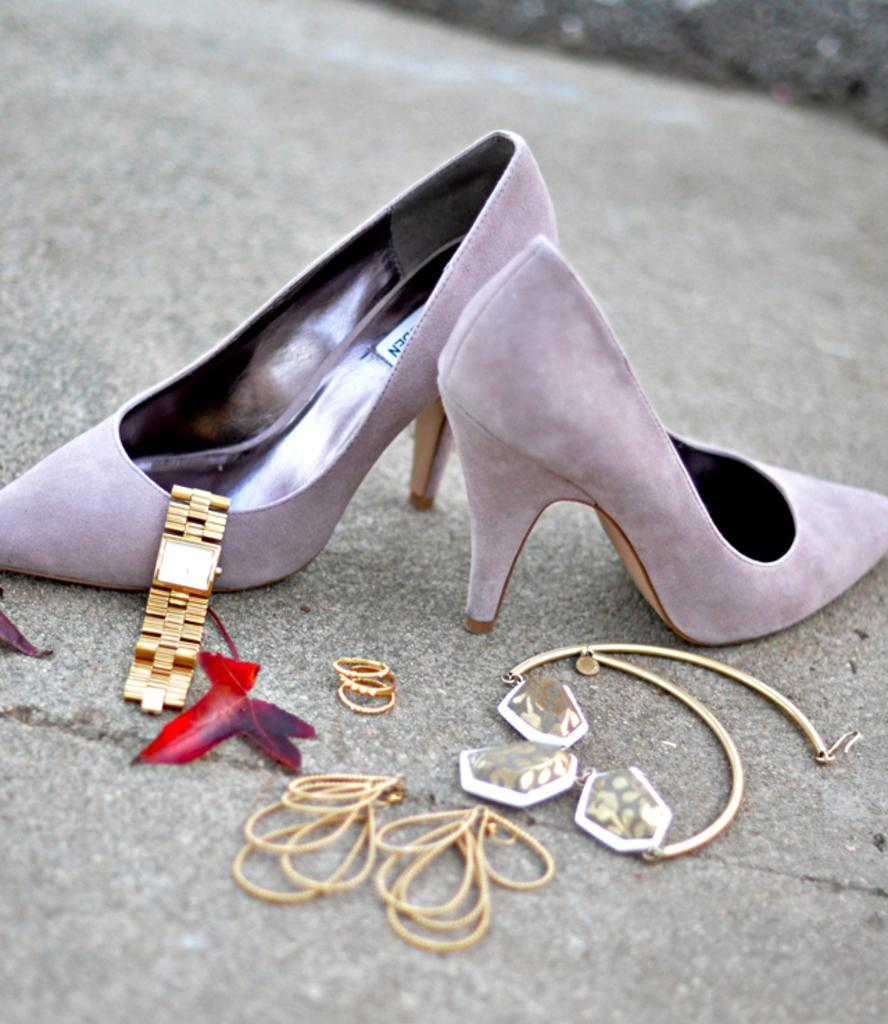What type of accessory is visible in the image? There is a wrist watch in the image. What else can be seen on the ground in the image? There are a few things on the ground in the image. Can you describe the background of the image? The background of the image is blurry. What type of lock can be seen in the image? There is no lock present in the image. Is there a battle taking place in the image? There is no battle depicted in the image. 